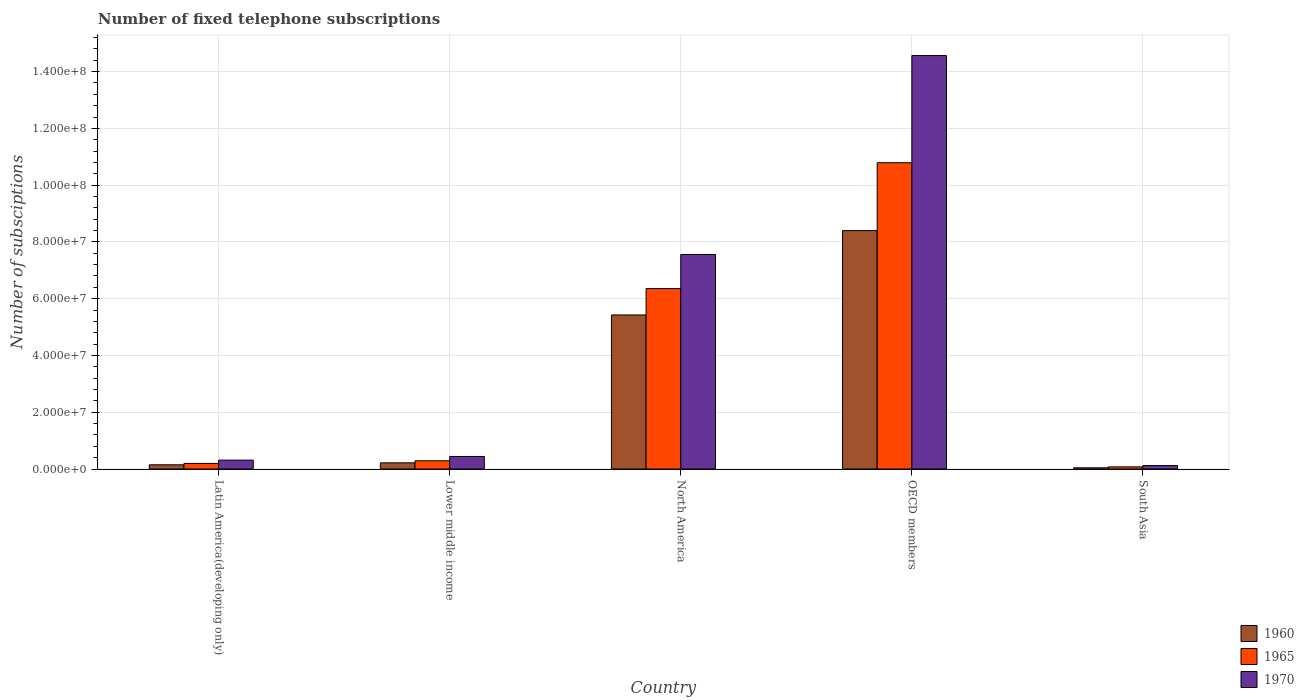How many different coloured bars are there?
Your response must be concise. 3. Are the number of bars per tick equal to the number of legend labels?
Ensure brevity in your answer.  Yes. Are the number of bars on each tick of the X-axis equal?
Offer a very short reply. Yes. In how many cases, is the number of bars for a given country not equal to the number of legend labels?
Make the answer very short. 0. What is the number of fixed telephone subscriptions in 1970 in North America?
Offer a very short reply. 7.56e+07. Across all countries, what is the maximum number of fixed telephone subscriptions in 1960?
Offer a very short reply. 8.40e+07. Across all countries, what is the minimum number of fixed telephone subscriptions in 1960?
Ensure brevity in your answer.  4.30e+05. What is the total number of fixed telephone subscriptions in 1960 in the graph?
Make the answer very short. 1.42e+08. What is the difference between the number of fixed telephone subscriptions in 1965 in North America and that in South Asia?
Your answer should be very brief. 6.28e+07. What is the difference between the number of fixed telephone subscriptions in 1965 in Lower middle income and the number of fixed telephone subscriptions in 1970 in OECD members?
Keep it short and to the point. -1.43e+08. What is the average number of fixed telephone subscriptions in 1970 per country?
Offer a very short reply. 4.60e+07. What is the difference between the number of fixed telephone subscriptions of/in 1970 and number of fixed telephone subscriptions of/in 1960 in North America?
Give a very brief answer. 2.13e+07. In how many countries, is the number of fixed telephone subscriptions in 1965 greater than 112000000?
Your answer should be compact. 0. What is the ratio of the number of fixed telephone subscriptions in 1965 in Latin America(developing only) to that in North America?
Provide a short and direct response. 0.03. What is the difference between the highest and the second highest number of fixed telephone subscriptions in 1970?
Ensure brevity in your answer.  -7.12e+07. What is the difference between the highest and the lowest number of fixed telephone subscriptions in 1960?
Your answer should be very brief. 8.36e+07. In how many countries, is the number of fixed telephone subscriptions in 1970 greater than the average number of fixed telephone subscriptions in 1970 taken over all countries?
Your response must be concise. 2. What does the 2nd bar from the left in South Asia represents?
Provide a short and direct response. 1965. What does the 2nd bar from the right in OECD members represents?
Ensure brevity in your answer.  1965. Is it the case that in every country, the sum of the number of fixed telephone subscriptions in 1970 and number of fixed telephone subscriptions in 1960 is greater than the number of fixed telephone subscriptions in 1965?
Keep it short and to the point. Yes. How many countries are there in the graph?
Provide a succinct answer. 5. Are the values on the major ticks of Y-axis written in scientific E-notation?
Offer a terse response. Yes. How many legend labels are there?
Offer a terse response. 3. What is the title of the graph?
Give a very brief answer. Number of fixed telephone subscriptions. What is the label or title of the X-axis?
Your answer should be very brief. Country. What is the label or title of the Y-axis?
Provide a short and direct response. Number of subsciptions. What is the Number of subsciptions in 1960 in Latin America(developing only)?
Make the answer very short. 1.48e+06. What is the Number of subsciptions in 1965 in Latin America(developing only)?
Your answer should be compact. 1.97e+06. What is the Number of subsciptions of 1970 in Latin America(developing only)?
Offer a very short reply. 3.13e+06. What is the Number of subsciptions in 1960 in Lower middle income?
Keep it short and to the point. 2.17e+06. What is the Number of subsciptions in 1965 in Lower middle income?
Your answer should be compact. 2.90e+06. What is the Number of subsciptions in 1970 in Lower middle income?
Offer a very short reply. 4.42e+06. What is the Number of subsciptions in 1960 in North America?
Offer a very short reply. 5.43e+07. What is the Number of subsciptions in 1965 in North America?
Your response must be concise. 6.36e+07. What is the Number of subsciptions of 1970 in North America?
Keep it short and to the point. 7.56e+07. What is the Number of subsciptions in 1960 in OECD members?
Provide a succinct answer. 8.40e+07. What is the Number of subsciptions in 1965 in OECD members?
Ensure brevity in your answer.  1.08e+08. What is the Number of subsciptions of 1970 in OECD members?
Your answer should be very brief. 1.46e+08. What is the Number of subsciptions of 1960 in South Asia?
Your answer should be very brief. 4.30e+05. What is the Number of subsciptions in 1965 in South Asia?
Make the answer very short. 7.57e+05. What is the Number of subsciptions of 1970 in South Asia?
Provide a short and direct response. 1.22e+06. Across all countries, what is the maximum Number of subsciptions of 1960?
Your answer should be very brief. 8.40e+07. Across all countries, what is the maximum Number of subsciptions in 1965?
Your answer should be very brief. 1.08e+08. Across all countries, what is the maximum Number of subsciptions in 1970?
Offer a very short reply. 1.46e+08. Across all countries, what is the minimum Number of subsciptions in 1960?
Offer a very short reply. 4.30e+05. Across all countries, what is the minimum Number of subsciptions of 1965?
Offer a very short reply. 7.57e+05. Across all countries, what is the minimum Number of subsciptions in 1970?
Offer a very short reply. 1.22e+06. What is the total Number of subsciptions in 1960 in the graph?
Provide a succinct answer. 1.42e+08. What is the total Number of subsciptions of 1965 in the graph?
Provide a succinct answer. 1.77e+08. What is the total Number of subsciptions of 1970 in the graph?
Provide a short and direct response. 2.30e+08. What is the difference between the Number of subsciptions of 1960 in Latin America(developing only) and that in Lower middle income?
Offer a terse response. -6.92e+05. What is the difference between the Number of subsciptions in 1965 in Latin America(developing only) and that in Lower middle income?
Keep it short and to the point. -9.30e+05. What is the difference between the Number of subsciptions in 1970 in Latin America(developing only) and that in Lower middle income?
Give a very brief answer. -1.29e+06. What is the difference between the Number of subsciptions in 1960 in Latin America(developing only) and that in North America?
Keep it short and to the point. -5.28e+07. What is the difference between the Number of subsciptions of 1965 in Latin America(developing only) and that in North America?
Your answer should be very brief. -6.16e+07. What is the difference between the Number of subsciptions in 1970 in Latin America(developing only) and that in North America?
Provide a succinct answer. -7.24e+07. What is the difference between the Number of subsciptions of 1960 in Latin America(developing only) and that in OECD members?
Your answer should be very brief. -8.25e+07. What is the difference between the Number of subsciptions of 1965 in Latin America(developing only) and that in OECD members?
Make the answer very short. -1.06e+08. What is the difference between the Number of subsciptions in 1970 in Latin America(developing only) and that in OECD members?
Your answer should be compact. -1.43e+08. What is the difference between the Number of subsciptions in 1960 in Latin America(developing only) and that in South Asia?
Give a very brief answer. 1.05e+06. What is the difference between the Number of subsciptions in 1965 in Latin America(developing only) and that in South Asia?
Your answer should be compact. 1.21e+06. What is the difference between the Number of subsciptions in 1970 in Latin America(developing only) and that in South Asia?
Provide a short and direct response. 1.91e+06. What is the difference between the Number of subsciptions of 1960 in Lower middle income and that in North America?
Your response must be concise. -5.21e+07. What is the difference between the Number of subsciptions in 1965 in Lower middle income and that in North America?
Offer a very short reply. -6.07e+07. What is the difference between the Number of subsciptions of 1970 in Lower middle income and that in North America?
Ensure brevity in your answer.  -7.12e+07. What is the difference between the Number of subsciptions of 1960 in Lower middle income and that in OECD members?
Your answer should be very brief. -8.18e+07. What is the difference between the Number of subsciptions in 1965 in Lower middle income and that in OECD members?
Your answer should be very brief. -1.05e+08. What is the difference between the Number of subsciptions in 1970 in Lower middle income and that in OECD members?
Keep it short and to the point. -1.41e+08. What is the difference between the Number of subsciptions of 1960 in Lower middle income and that in South Asia?
Provide a short and direct response. 1.74e+06. What is the difference between the Number of subsciptions of 1965 in Lower middle income and that in South Asia?
Your response must be concise. 2.14e+06. What is the difference between the Number of subsciptions of 1970 in Lower middle income and that in South Asia?
Your answer should be compact. 3.20e+06. What is the difference between the Number of subsciptions in 1960 in North America and that in OECD members?
Give a very brief answer. -2.97e+07. What is the difference between the Number of subsciptions in 1965 in North America and that in OECD members?
Provide a short and direct response. -4.43e+07. What is the difference between the Number of subsciptions in 1970 in North America and that in OECD members?
Give a very brief answer. -7.01e+07. What is the difference between the Number of subsciptions of 1960 in North America and that in South Asia?
Provide a succinct answer. 5.38e+07. What is the difference between the Number of subsciptions of 1965 in North America and that in South Asia?
Provide a succinct answer. 6.28e+07. What is the difference between the Number of subsciptions in 1970 in North America and that in South Asia?
Your answer should be compact. 7.43e+07. What is the difference between the Number of subsciptions in 1960 in OECD members and that in South Asia?
Your response must be concise. 8.36e+07. What is the difference between the Number of subsciptions of 1965 in OECD members and that in South Asia?
Your answer should be compact. 1.07e+08. What is the difference between the Number of subsciptions in 1970 in OECD members and that in South Asia?
Give a very brief answer. 1.44e+08. What is the difference between the Number of subsciptions of 1960 in Latin America(developing only) and the Number of subsciptions of 1965 in Lower middle income?
Your answer should be very brief. -1.42e+06. What is the difference between the Number of subsciptions in 1960 in Latin America(developing only) and the Number of subsciptions in 1970 in Lower middle income?
Provide a succinct answer. -2.94e+06. What is the difference between the Number of subsciptions in 1965 in Latin America(developing only) and the Number of subsciptions in 1970 in Lower middle income?
Your answer should be compact. -2.45e+06. What is the difference between the Number of subsciptions in 1960 in Latin America(developing only) and the Number of subsciptions in 1965 in North America?
Make the answer very short. -6.21e+07. What is the difference between the Number of subsciptions of 1960 in Latin America(developing only) and the Number of subsciptions of 1970 in North America?
Provide a short and direct response. -7.41e+07. What is the difference between the Number of subsciptions in 1965 in Latin America(developing only) and the Number of subsciptions in 1970 in North America?
Keep it short and to the point. -7.36e+07. What is the difference between the Number of subsciptions of 1960 in Latin America(developing only) and the Number of subsciptions of 1965 in OECD members?
Offer a very short reply. -1.06e+08. What is the difference between the Number of subsciptions in 1960 in Latin America(developing only) and the Number of subsciptions in 1970 in OECD members?
Your answer should be very brief. -1.44e+08. What is the difference between the Number of subsciptions of 1965 in Latin America(developing only) and the Number of subsciptions of 1970 in OECD members?
Keep it short and to the point. -1.44e+08. What is the difference between the Number of subsciptions in 1960 in Latin America(developing only) and the Number of subsciptions in 1965 in South Asia?
Your answer should be compact. 7.25e+05. What is the difference between the Number of subsciptions of 1960 in Latin America(developing only) and the Number of subsciptions of 1970 in South Asia?
Offer a very short reply. 2.62e+05. What is the difference between the Number of subsciptions in 1965 in Latin America(developing only) and the Number of subsciptions in 1970 in South Asia?
Provide a succinct answer. 7.50e+05. What is the difference between the Number of subsciptions in 1960 in Lower middle income and the Number of subsciptions in 1965 in North America?
Keep it short and to the point. -6.14e+07. What is the difference between the Number of subsciptions in 1960 in Lower middle income and the Number of subsciptions in 1970 in North America?
Provide a short and direct response. -7.34e+07. What is the difference between the Number of subsciptions in 1965 in Lower middle income and the Number of subsciptions in 1970 in North America?
Your answer should be very brief. -7.27e+07. What is the difference between the Number of subsciptions in 1960 in Lower middle income and the Number of subsciptions in 1965 in OECD members?
Offer a terse response. -1.06e+08. What is the difference between the Number of subsciptions of 1960 in Lower middle income and the Number of subsciptions of 1970 in OECD members?
Keep it short and to the point. -1.43e+08. What is the difference between the Number of subsciptions of 1965 in Lower middle income and the Number of subsciptions of 1970 in OECD members?
Keep it short and to the point. -1.43e+08. What is the difference between the Number of subsciptions of 1960 in Lower middle income and the Number of subsciptions of 1965 in South Asia?
Offer a terse response. 1.42e+06. What is the difference between the Number of subsciptions of 1960 in Lower middle income and the Number of subsciptions of 1970 in South Asia?
Your answer should be compact. 9.54e+05. What is the difference between the Number of subsciptions of 1965 in Lower middle income and the Number of subsciptions of 1970 in South Asia?
Your answer should be very brief. 1.68e+06. What is the difference between the Number of subsciptions of 1960 in North America and the Number of subsciptions of 1965 in OECD members?
Offer a very short reply. -5.36e+07. What is the difference between the Number of subsciptions in 1960 in North America and the Number of subsciptions in 1970 in OECD members?
Make the answer very short. -9.14e+07. What is the difference between the Number of subsciptions of 1965 in North America and the Number of subsciptions of 1970 in OECD members?
Ensure brevity in your answer.  -8.21e+07. What is the difference between the Number of subsciptions in 1960 in North America and the Number of subsciptions in 1965 in South Asia?
Keep it short and to the point. 5.35e+07. What is the difference between the Number of subsciptions in 1960 in North America and the Number of subsciptions in 1970 in South Asia?
Offer a terse response. 5.30e+07. What is the difference between the Number of subsciptions of 1965 in North America and the Number of subsciptions of 1970 in South Asia?
Give a very brief answer. 6.24e+07. What is the difference between the Number of subsciptions in 1960 in OECD members and the Number of subsciptions in 1965 in South Asia?
Provide a succinct answer. 8.32e+07. What is the difference between the Number of subsciptions of 1960 in OECD members and the Number of subsciptions of 1970 in South Asia?
Ensure brevity in your answer.  8.28e+07. What is the difference between the Number of subsciptions of 1965 in OECD members and the Number of subsciptions of 1970 in South Asia?
Ensure brevity in your answer.  1.07e+08. What is the average Number of subsciptions in 1960 per country?
Your answer should be compact. 2.85e+07. What is the average Number of subsciptions of 1965 per country?
Make the answer very short. 3.54e+07. What is the average Number of subsciptions in 1970 per country?
Your answer should be very brief. 4.60e+07. What is the difference between the Number of subsciptions of 1960 and Number of subsciptions of 1965 in Latin America(developing only)?
Your response must be concise. -4.88e+05. What is the difference between the Number of subsciptions of 1960 and Number of subsciptions of 1970 in Latin America(developing only)?
Offer a terse response. -1.64e+06. What is the difference between the Number of subsciptions in 1965 and Number of subsciptions in 1970 in Latin America(developing only)?
Your response must be concise. -1.16e+06. What is the difference between the Number of subsciptions in 1960 and Number of subsciptions in 1965 in Lower middle income?
Your response must be concise. -7.27e+05. What is the difference between the Number of subsciptions of 1960 and Number of subsciptions of 1970 in Lower middle income?
Keep it short and to the point. -2.24e+06. What is the difference between the Number of subsciptions of 1965 and Number of subsciptions of 1970 in Lower middle income?
Your response must be concise. -1.52e+06. What is the difference between the Number of subsciptions in 1960 and Number of subsciptions in 1965 in North America?
Keep it short and to the point. -9.30e+06. What is the difference between the Number of subsciptions in 1960 and Number of subsciptions in 1970 in North America?
Provide a succinct answer. -2.13e+07. What is the difference between the Number of subsciptions in 1965 and Number of subsciptions in 1970 in North America?
Make the answer very short. -1.20e+07. What is the difference between the Number of subsciptions of 1960 and Number of subsciptions of 1965 in OECD members?
Your answer should be compact. -2.39e+07. What is the difference between the Number of subsciptions in 1960 and Number of subsciptions in 1970 in OECD members?
Your answer should be compact. -6.17e+07. What is the difference between the Number of subsciptions of 1965 and Number of subsciptions of 1970 in OECD members?
Your response must be concise. -3.78e+07. What is the difference between the Number of subsciptions of 1960 and Number of subsciptions of 1965 in South Asia?
Provide a short and direct response. -3.27e+05. What is the difference between the Number of subsciptions in 1960 and Number of subsciptions in 1970 in South Asia?
Make the answer very short. -7.90e+05. What is the difference between the Number of subsciptions of 1965 and Number of subsciptions of 1970 in South Asia?
Ensure brevity in your answer.  -4.63e+05. What is the ratio of the Number of subsciptions of 1960 in Latin America(developing only) to that in Lower middle income?
Offer a very short reply. 0.68. What is the ratio of the Number of subsciptions in 1965 in Latin America(developing only) to that in Lower middle income?
Make the answer very short. 0.68. What is the ratio of the Number of subsciptions of 1970 in Latin America(developing only) to that in Lower middle income?
Provide a succinct answer. 0.71. What is the ratio of the Number of subsciptions in 1960 in Latin America(developing only) to that in North America?
Give a very brief answer. 0.03. What is the ratio of the Number of subsciptions of 1965 in Latin America(developing only) to that in North America?
Offer a terse response. 0.03. What is the ratio of the Number of subsciptions in 1970 in Latin America(developing only) to that in North America?
Provide a succinct answer. 0.04. What is the ratio of the Number of subsciptions of 1960 in Latin America(developing only) to that in OECD members?
Give a very brief answer. 0.02. What is the ratio of the Number of subsciptions in 1965 in Latin America(developing only) to that in OECD members?
Keep it short and to the point. 0.02. What is the ratio of the Number of subsciptions in 1970 in Latin America(developing only) to that in OECD members?
Your answer should be very brief. 0.02. What is the ratio of the Number of subsciptions of 1960 in Latin America(developing only) to that in South Asia?
Give a very brief answer. 3.45. What is the ratio of the Number of subsciptions of 1965 in Latin America(developing only) to that in South Asia?
Give a very brief answer. 2.6. What is the ratio of the Number of subsciptions in 1970 in Latin America(developing only) to that in South Asia?
Offer a terse response. 2.56. What is the ratio of the Number of subsciptions of 1960 in Lower middle income to that in North America?
Offer a terse response. 0.04. What is the ratio of the Number of subsciptions in 1965 in Lower middle income to that in North America?
Ensure brevity in your answer.  0.05. What is the ratio of the Number of subsciptions in 1970 in Lower middle income to that in North America?
Your response must be concise. 0.06. What is the ratio of the Number of subsciptions of 1960 in Lower middle income to that in OECD members?
Your answer should be very brief. 0.03. What is the ratio of the Number of subsciptions in 1965 in Lower middle income to that in OECD members?
Offer a very short reply. 0.03. What is the ratio of the Number of subsciptions of 1970 in Lower middle income to that in OECD members?
Your response must be concise. 0.03. What is the ratio of the Number of subsciptions of 1960 in Lower middle income to that in South Asia?
Make the answer very short. 5.06. What is the ratio of the Number of subsciptions of 1965 in Lower middle income to that in South Asia?
Make the answer very short. 3.83. What is the ratio of the Number of subsciptions of 1970 in Lower middle income to that in South Asia?
Your answer should be compact. 3.62. What is the ratio of the Number of subsciptions of 1960 in North America to that in OECD members?
Provide a succinct answer. 0.65. What is the ratio of the Number of subsciptions of 1965 in North America to that in OECD members?
Your answer should be very brief. 0.59. What is the ratio of the Number of subsciptions of 1970 in North America to that in OECD members?
Your answer should be compact. 0.52. What is the ratio of the Number of subsciptions in 1960 in North America to that in South Asia?
Your response must be concise. 126.3. What is the ratio of the Number of subsciptions in 1965 in North America to that in South Asia?
Your answer should be compact. 84.02. What is the ratio of the Number of subsciptions in 1970 in North America to that in South Asia?
Offer a very short reply. 61.94. What is the ratio of the Number of subsciptions of 1960 in OECD members to that in South Asia?
Give a very brief answer. 195.46. What is the ratio of the Number of subsciptions of 1965 in OECD members to that in South Asia?
Make the answer very short. 142.6. What is the ratio of the Number of subsciptions in 1970 in OECD members to that in South Asia?
Your answer should be compact. 119.38. What is the difference between the highest and the second highest Number of subsciptions of 1960?
Your response must be concise. 2.97e+07. What is the difference between the highest and the second highest Number of subsciptions of 1965?
Your response must be concise. 4.43e+07. What is the difference between the highest and the second highest Number of subsciptions in 1970?
Make the answer very short. 7.01e+07. What is the difference between the highest and the lowest Number of subsciptions in 1960?
Make the answer very short. 8.36e+07. What is the difference between the highest and the lowest Number of subsciptions in 1965?
Your answer should be compact. 1.07e+08. What is the difference between the highest and the lowest Number of subsciptions of 1970?
Give a very brief answer. 1.44e+08. 